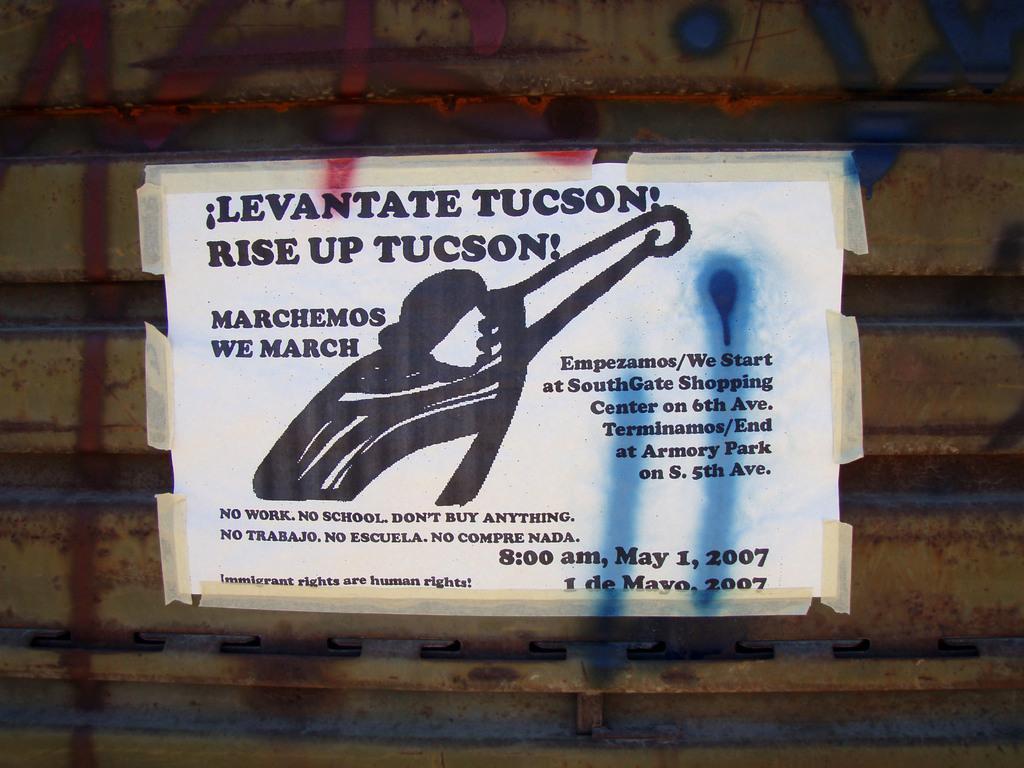In one or two sentences, can you explain what this image depicts? In this picture we can see a poster on a surface and on this poster we can see an object and some text. 